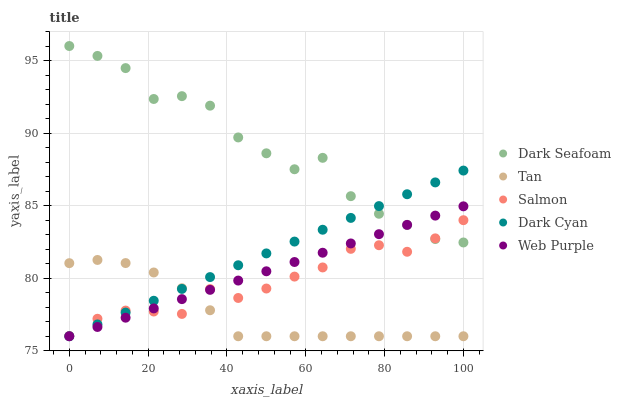Does Tan have the minimum area under the curve?
Answer yes or no. Yes. Does Dark Seafoam have the maximum area under the curve?
Answer yes or no. Yes. Does Web Purple have the minimum area under the curve?
Answer yes or no. No. Does Web Purple have the maximum area under the curve?
Answer yes or no. No. Is Web Purple the smoothest?
Answer yes or no. Yes. Is Dark Seafoam the roughest?
Answer yes or no. Yes. Is Dark Seafoam the smoothest?
Answer yes or no. No. Is Web Purple the roughest?
Answer yes or no. No. Does Dark Cyan have the lowest value?
Answer yes or no. Yes. Does Dark Seafoam have the lowest value?
Answer yes or no. No. Does Dark Seafoam have the highest value?
Answer yes or no. Yes. Does Web Purple have the highest value?
Answer yes or no. No. Is Tan less than Dark Seafoam?
Answer yes or no. Yes. Is Dark Seafoam greater than Tan?
Answer yes or no. Yes. Does Dark Cyan intersect Salmon?
Answer yes or no. Yes. Is Dark Cyan less than Salmon?
Answer yes or no. No. Is Dark Cyan greater than Salmon?
Answer yes or no. No. Does Tan intersect Dark Seafoam?
Answer yes or no. No. 